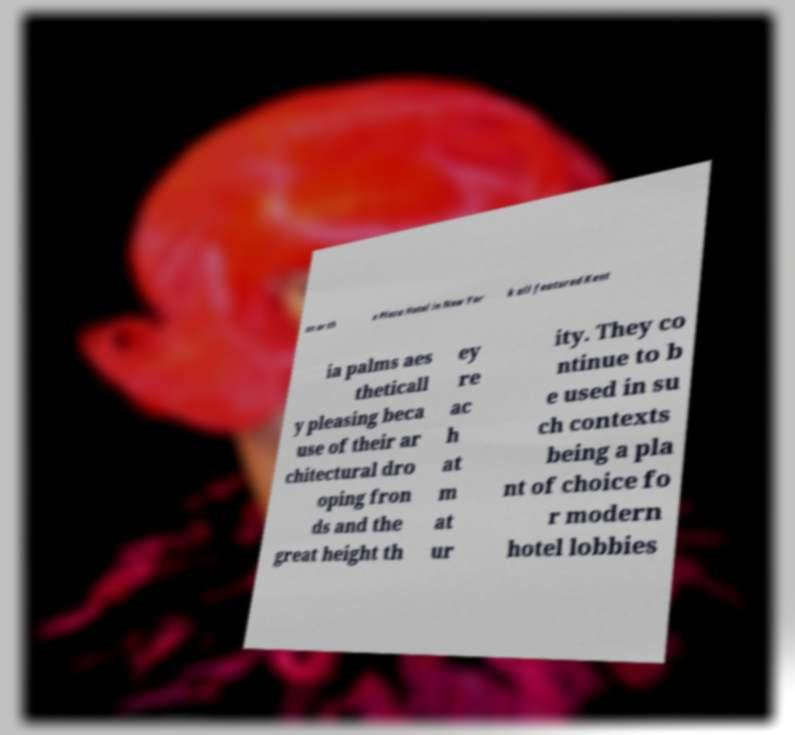Can you accurately transcribe the text from the provided image for me? on or th e Plaza Hotel in New Yor k all featured Kent ia palms aes theticall y pleasing beca use of their ar chitectural dro oping fron ds and the great height th ey re ac h at m at ur ity. They co ntinue to b e used in su ch contexts being a pla nt of choice fo r modern hotel lobbies 